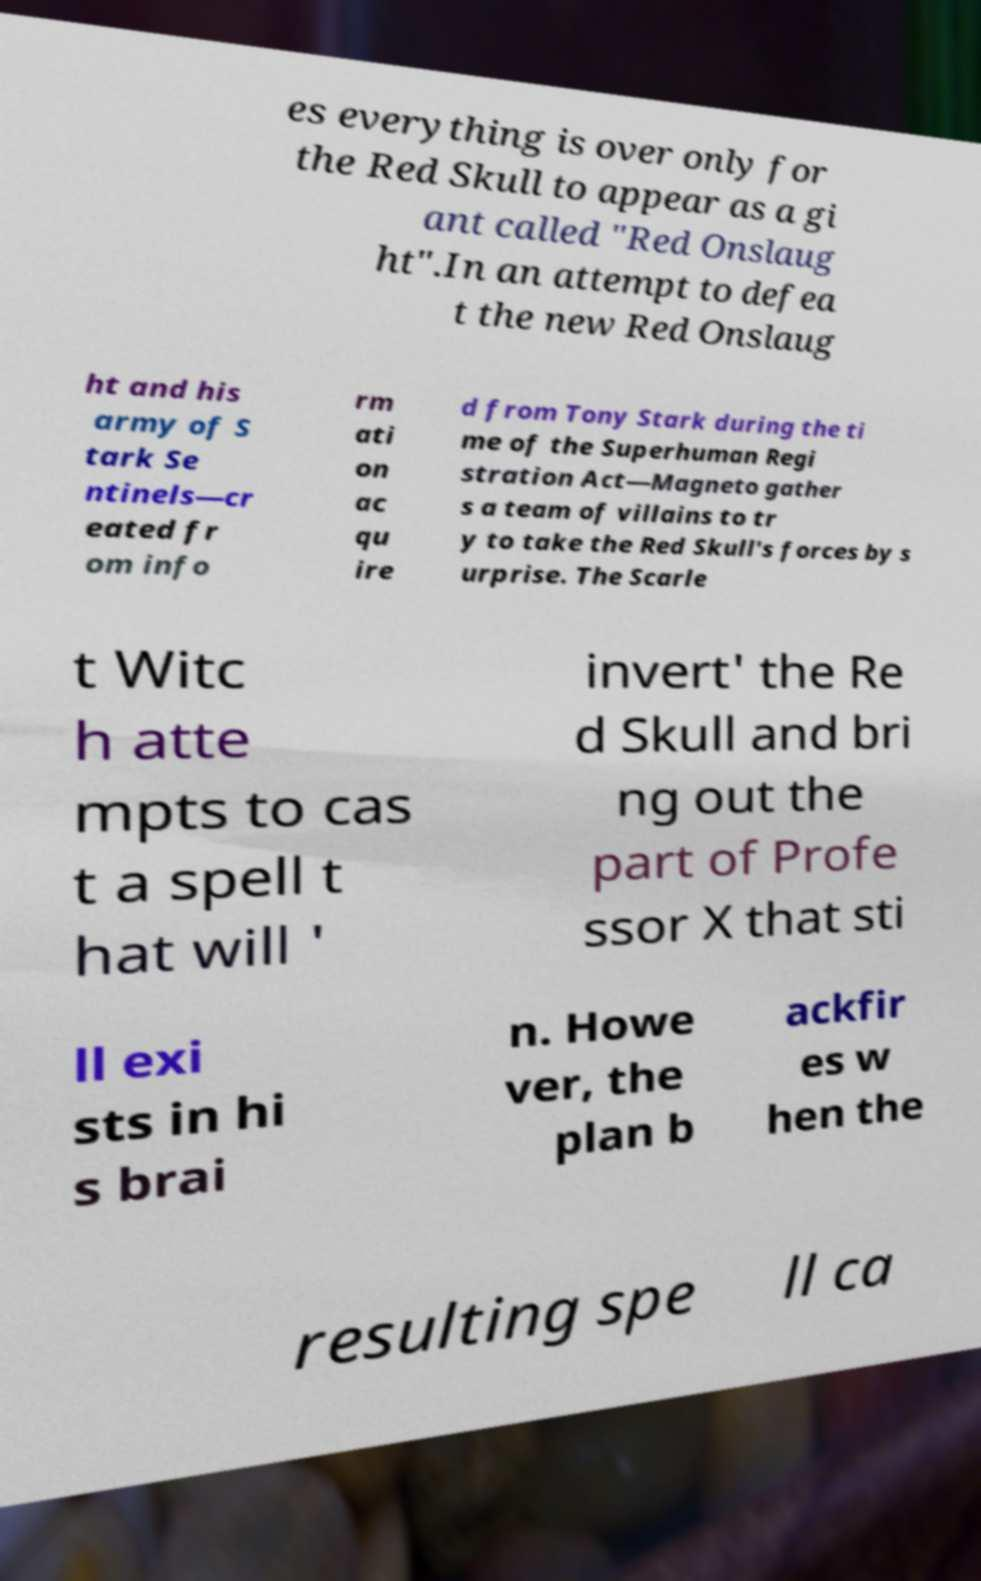Could you extract and type out the text from this image? es everything is over only for the Red Skull to appear as a gi ant called "Red Onslaug ht".In an attempt to defea t the new Red Onslaug ht and his army of S tark Se ntinels—cr eated fr om info rm ati on ac qu ire d from Tony Stark during the ti me of the Superhuman Regi stration Act—Magneto gather s a team of villains to tr y to take the Red Skull's forces by s urprise. The Scarle t Witc h atte mpts to cas t a spell t hat will ' invert' the Re d Skull and bri ng out the part of Profe ssor X that sti ll exi sts in hi s brai n. Howe ver, the plan b ackfir es w hen the resulting spe ll ca 